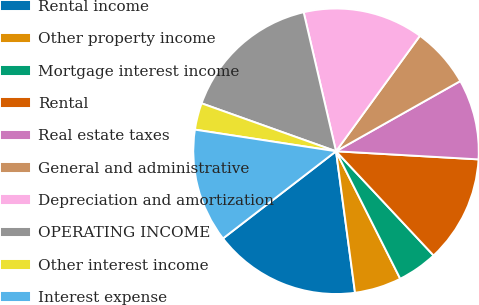Convert chart to OTSL. <chart><loc_0><loc_0><loc_500><loc_500><pie_chart><fcel>Rental income<fcel>Other property income<fcel>Mortgage interest income<fcel>Rental<fcel>Real estate taxes<fcel>General and administrative<fcel>Depreciation and amortization<fcel>OPERATING INCOME<fcel>Other interest income<fcel>Interest expense<nl><fcel>16.67%<fcel>5.3%<fcel>4.55%<fcel>12.12%<fcel>9.09%<fcel>6.82%<fcel>13.64%<fcel>15.91%<fcel>3.03%<fcel>12.88%<nl></chart> 